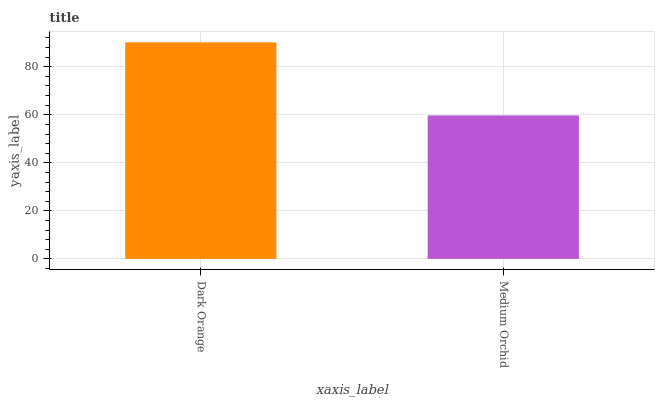Is Medium Orchid the minimum?
Answer yes or no. Yes. Is Dark Orange the maximum?
Answer yes or no. Yes. Is Medium Orchid the maximum?
Answer yes or no. No. Is Dark Orange greater than Medium Orchid?
Answer yes or no. Yes. Is Medium Orchid less than Dark Orange?
Answer yes or no. Yes. Is Medium Orchid greater than Dark Orange?
Answer yes or no. No. Is Dark Orange less than Medium Orchid?
Answer yes or no. No. Is Dark Orange the high median?
Answer yes or no. Yes. Is Medium Orchid the low median?
Answer yes or no. Yes. Is Medium Orchid the high median?
Answer yes or no. No. Is Dark Orange the low median?
Answer yes or no. No. 